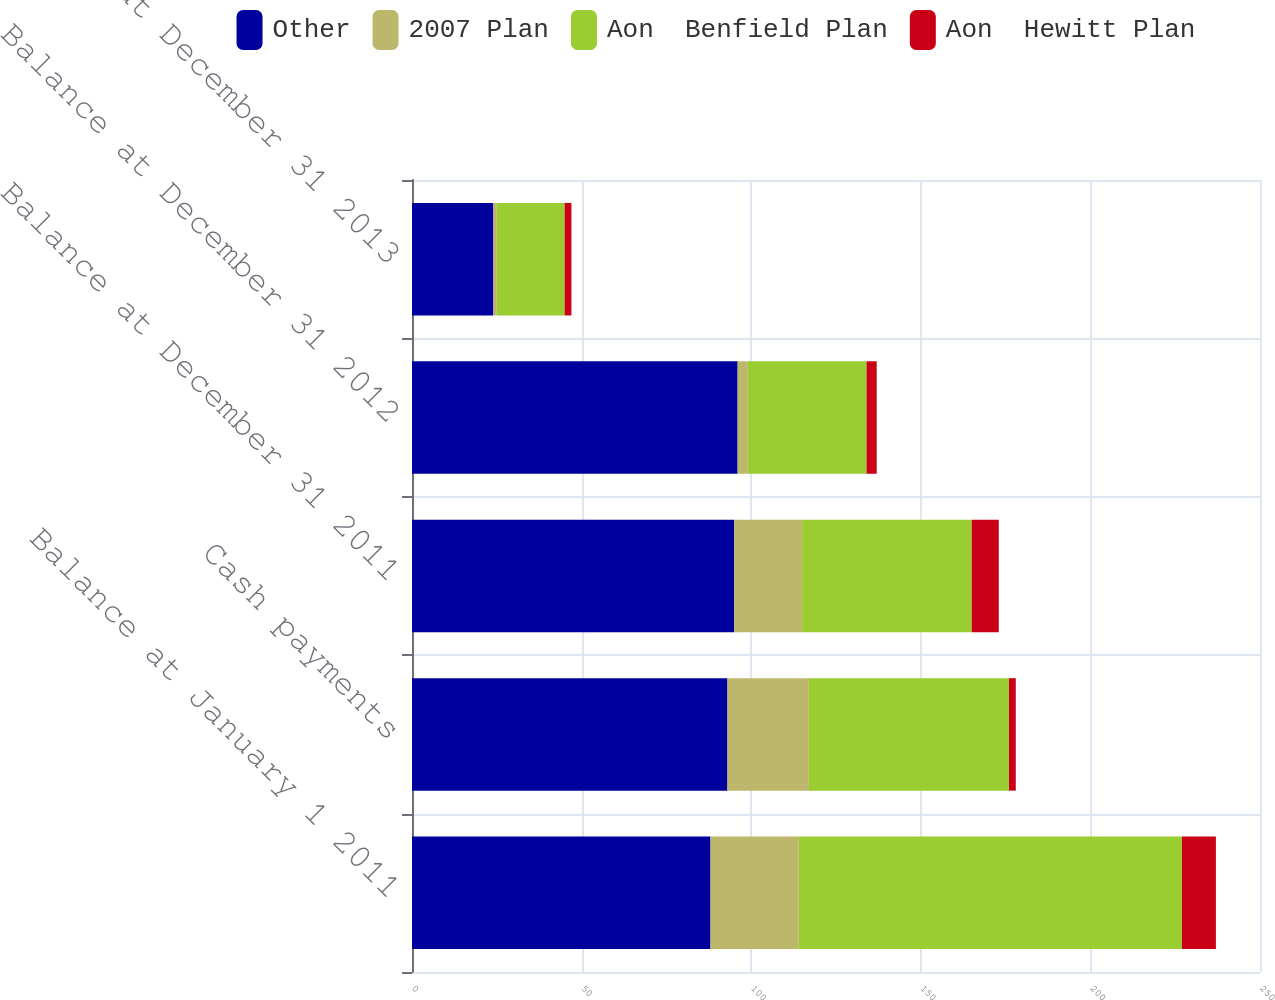Convert chart to OTSL. <chart><loc_0><loc_0><loc_500><loc_500><stacked_bar_chart><ecel><fcel>Balance at January 1 2011<fcel>Cash payments<fcel>Balance at December 31 2011<fcel>Balance at December 31 2012<fcel>Balance at December 31 2013<nl><fcel>Other<fcel>88<fcel>93<fcel>95<fcel>96<fcel>24<nl><fcel>2007 Plan<fcel>26<fcel>24<fcel>20<fcel>3<fcel>1<nl><fcel>Aon  Benfield Plan<fcel>113<fcel>59<fcel>50<fcel>35<fcel>20<nl><fcel>Aon  Hewitt Plan<fcel>10<fcel>2<fcel>8<fcel>3<fcel>2<nl></chart> 